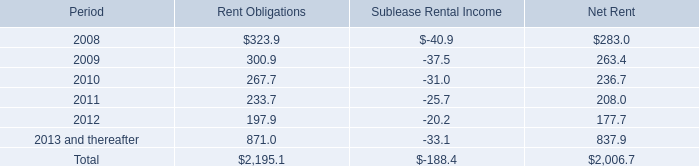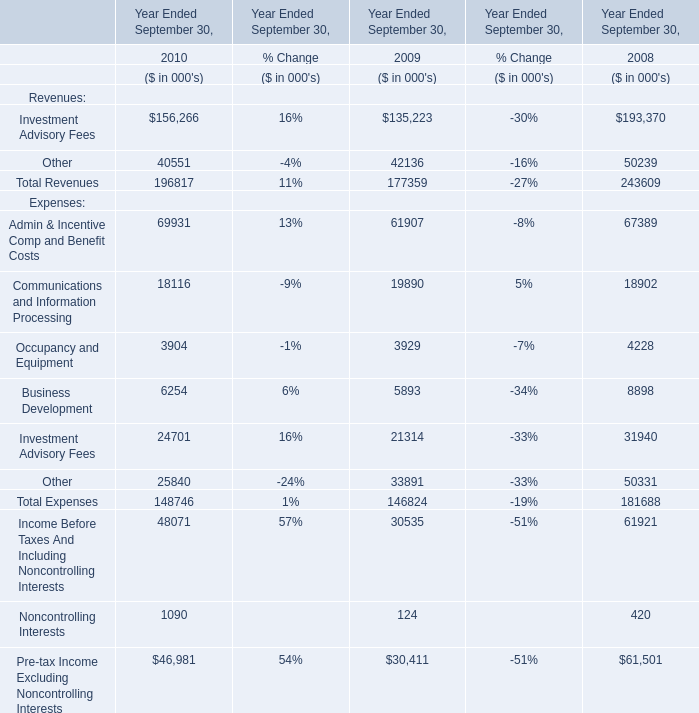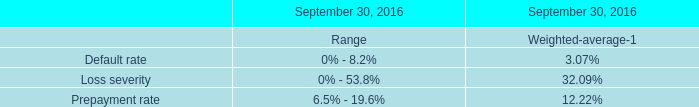What's the 10% of total expenses in 2010? (in thousand) 
Computations: (148746 * 0.1)
Answer: 14874.6. 